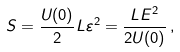<formula> <loc_0><loc_0><loc_500><loc_500>S = \frac { U ( 0 ) } { 2 } { L } \varepsilon ^ { 2 } = \frac { L E ^ { 2 } } { 2 U ( 0 ) } \, ,</formula> 